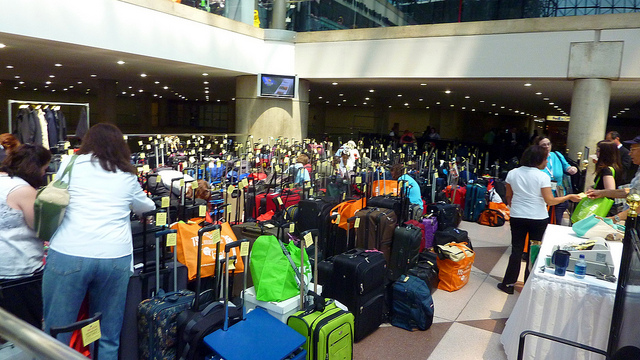<image>What colors are in the shades? It is ambiguous what colors are in the shades. It could be green, yellow, red, black, orange, or white. What colors are in the shades? I don't know what colors are in the shades. There is a mixture of different colors. 